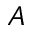<formula> <loc_0><loc_0><loc_500><loc_500>A</formula> 